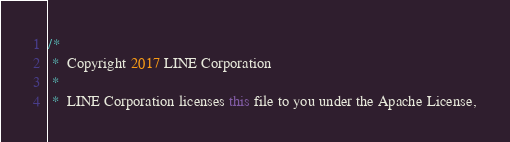Convert code to text. <code><loc_0><loc_0><loc_500><loc_500><_Java_>/*
 *  Copyright 2017 LINE Corporation
 *
 *  LINE Corporation licenses this file to you under the Apache License,</code> 